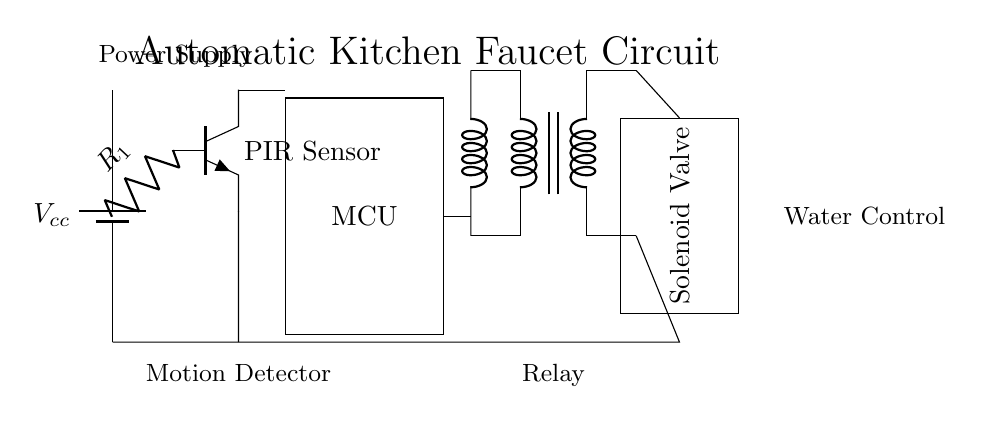What is the main component used to detect motion? The main component used to detect motion in this circuit is the PIR Sensor, which is indicated in the diagram as a specific component.
Answer: PIR Sensor What does MCU stand for in the circuit? MCU stands for Microcontroller Unit, which is depicted in the diagram as the rectangular block responsible for processing the sensor's signals.
Answer: Microcontroller Unit How is the solenoid valve activated? The solenoid valve is activated by the relay, which receives a signal from the microcontroller when motion is detected, allowing water to flow.
Answer: Relay What is the role of the battery in this circuit? The battery provides the necessary power supply, indicated in the diagram as Vcc, which energizes all components in the circuit.
Answer: Power Supply What connects the motion sensor to the microcontroller? The motion sensor is connected to the microcontroller via its collector terminal, which allows it to send signals when motion is detected.
Answer: Collector terminal How many components are directly involved in controlling the water flow? There are three components directly involved in controlling the water flow: the microcontroller, the relay, and the solenoid valve.
Answer: Three What is the function of the resistor labeled R1? The resistor labeled R1 is used to limit the current flowing from the motion sensor to the microcontroller, protecting it from excessive current.
Answer: Current limiting 